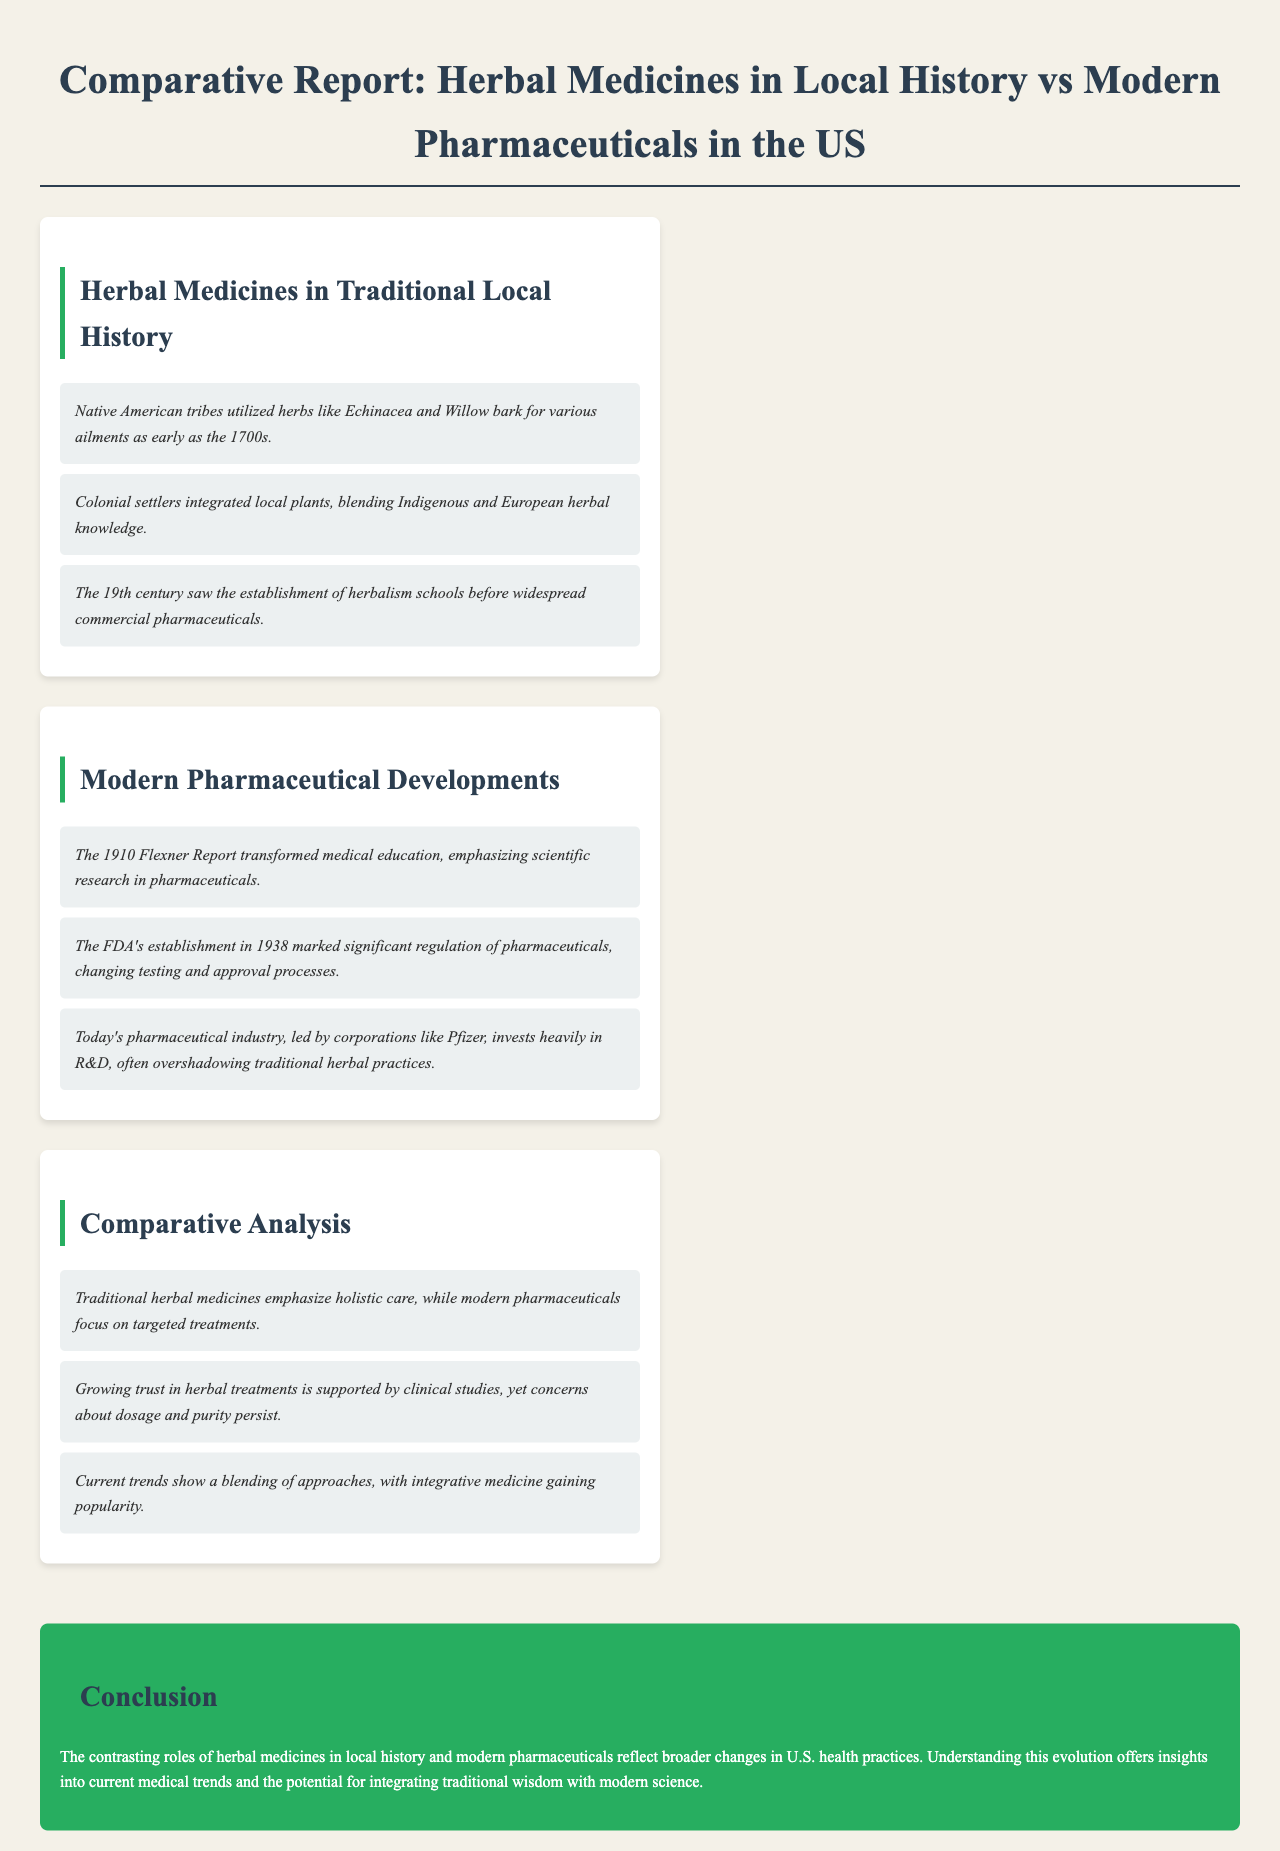What herbs were used by Native American tribes as early as the 1700s? The document states that Native American tribes utilized herbs like Echinacea and Willow bark for various ailments as early as the 1700s.
Answer: Echinacea and Willow bark What year did the FDA establish significant regulation of pharmaceuticals? According to the report, the FDA's establishment in 1938 marked significant regulation of pharmaceuticals.
Answer: 1938 What was the purpose of the 1910 Flexner Report? The document explains that the 1910 Flexner Report transformed medical education, emphasizing scientific research in pharmaceuticals.
Answer: Transform medical education What is one key difference between traditional herbal medicines and modern pharmaceuticals? The report notes that traditional herbal medicines emphasize holistic care, while modern pharmaceuticals focus on targeted treatments.
Answer: Holistic care vs. targeted treatments What role do clinical studies play in the perception of herbal treatments? The report states that growing trust in herbal treatments is supported by clinical studies, yet concerns about dosage and purity persist.
Answer: Supported by clinical studies What was the focus of herbalism schools established in the 19th century? The document mentions that the 19th century saw the establishment of herbalism schools before widespread commercial pharmaceuticals.
Answer: Herbalism education What trend is current in the relationship between herbal and pharmaceutical practices? The report highlights that current trends show a blending of approaches, with integrative medicine gaining popularity.
Answer: Blending of approaches What is emphasized in the document's conclusion regarding herbal medicines and modern pharmaceuticals? The conclusion states that the contrasting roles of herbal medicines and modern pharmaceuticals reflect broader changes in U.S. health practices.
Answer: Broader changes in U.S. health practices 